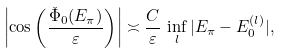Convert formula to latex. <formula><loc_0><loc_0><loc_500><loc_500>\left | \cos \left ( \frac { \check { \Phi } _ { 0 } ( E _ { \pi } ) } \varepsilon \right ) \right | \asymp \frac { C } \varepsilon \, \inf _ { l } | E _ { \pi } - E _ { 0 } ^ { ( l ) } | ,</formula> 